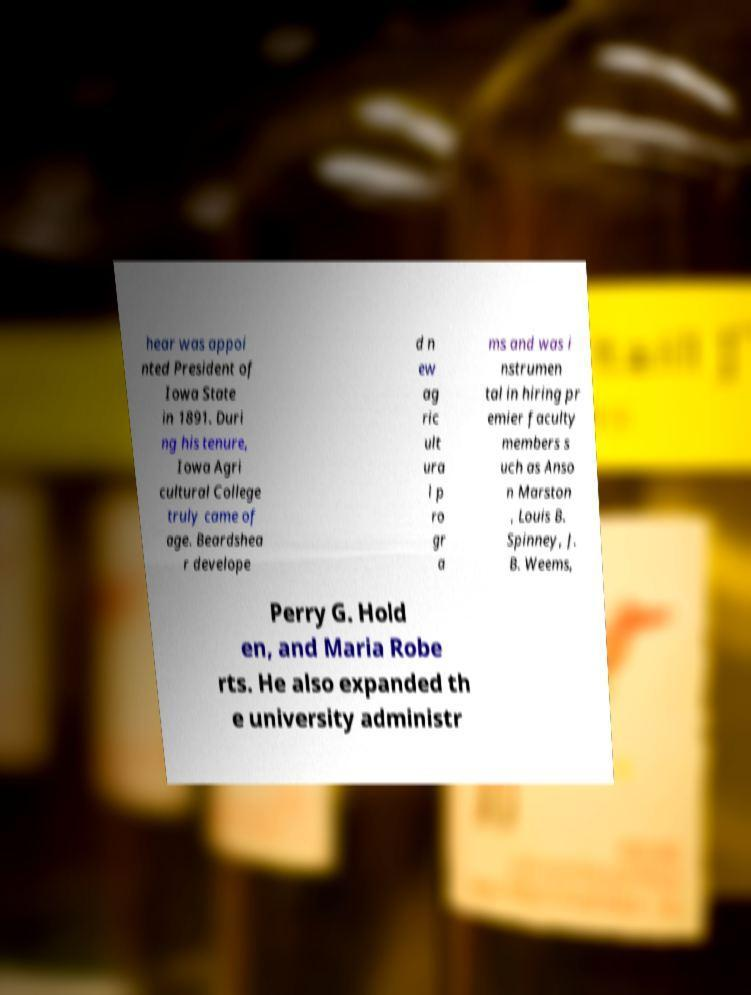What messages or text are displayed in this image? I need them in a readable, typed format. hear was appoi nted President of Iowa State in 1891. Duri ng his tenure, Iowa Agri cultural College truly came of age. Beardshea r develope d n ew ag ric ult ura l p ro gr a ms and was i nstrumen tal in hiring pr emier faculty members s uch as Anso n Marston , Louis B. Spinney, J. B. Weems, Perry G. Hold en, and Maria Robe rts. He also expanded th e university administr 